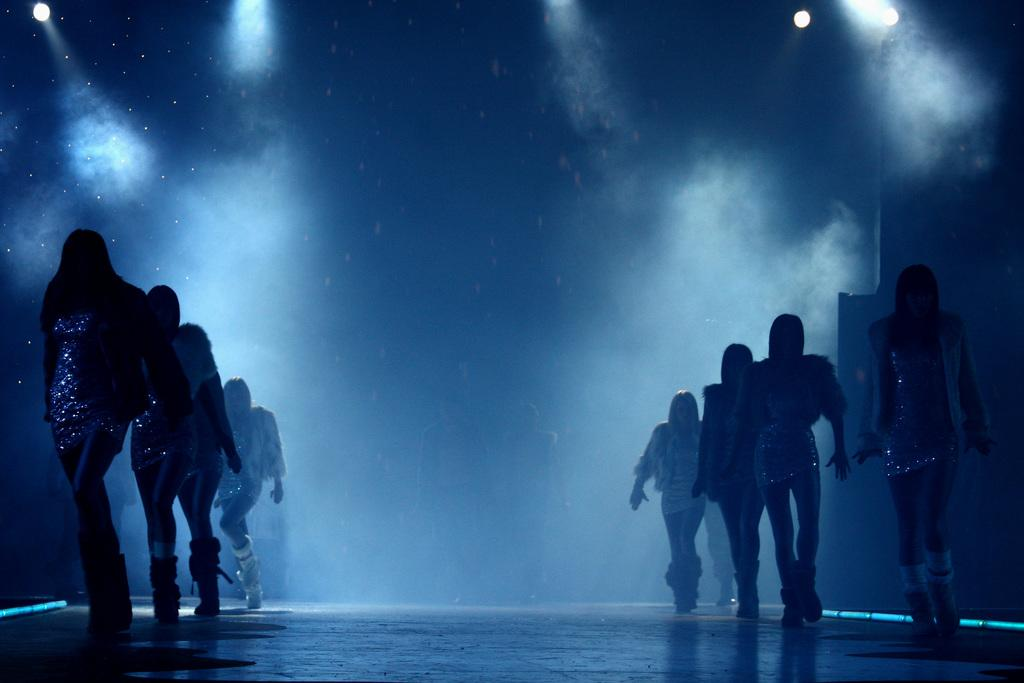How are the persons arranged in the image? There are persons in two lines in the image. What are the persons doing in the image? The persons are performing on a stage. What can be seen in the background of the image? There are lights in the background of the image. What is the atmosphere like in the image? There is smoke visible in the image, which might suggest a smoky or foggy atmosphere. Can you tell me how many cabbages are on stage with the performers? There are no cabbages present in the image; the performers are the main subjects on stage. Is there a lawyer present in the image? There is no mention of a lawyer in the image, and no such person is visible. 